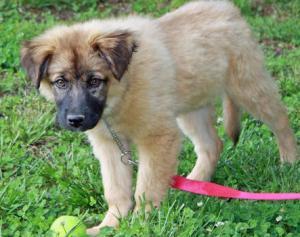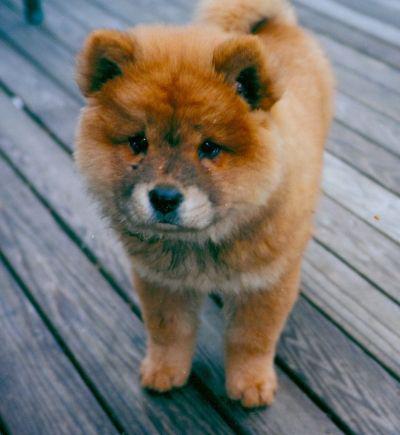The first image is the image on the left, the second image is the image on the right. For the images shown, is this caption "A man in a light blue shirt is holding two puppies." true? Answer yes or no. No. 